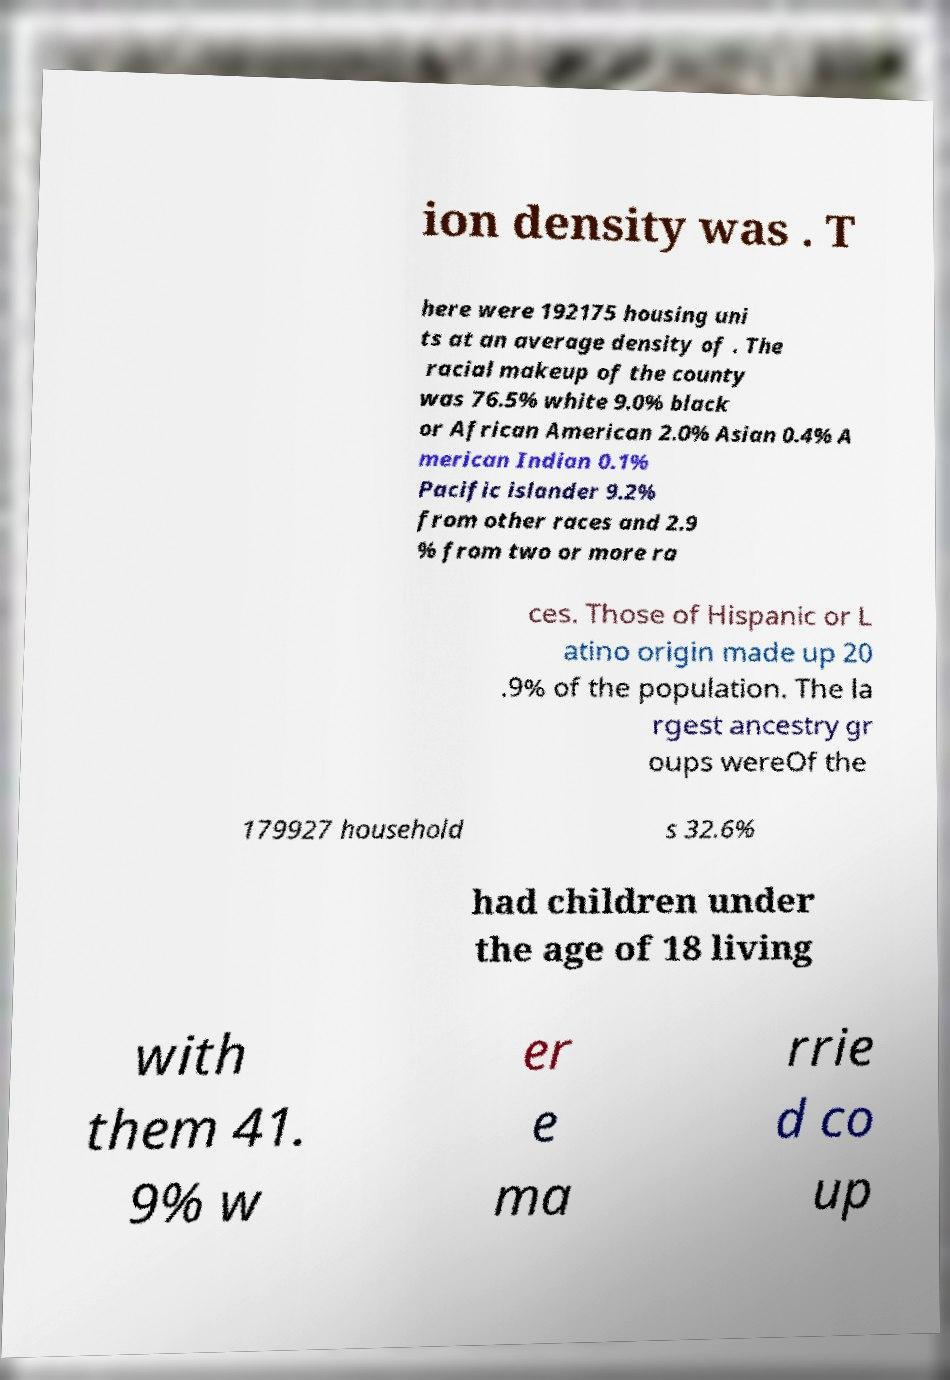What messages or text are displayed in this image? I need them in a readable, typed format. ion density was . T here were 192175 housing uni ts at an average density of . The racial makeup of the county was 76.5% white 9.0% black or African American 2.0% Asian 0.4% A merican Indian 0.1% Pacific islander 9.2% from other races and 2.9 % from two or more ra ces. Those of Hispanic or L atino origin made up 20 .9% of the population. The la rgest ancestry gr oups wereOf the 179927 household s 32.6% had children under the age of 18 living with them 41. 9% w er e ma rrie d co up 